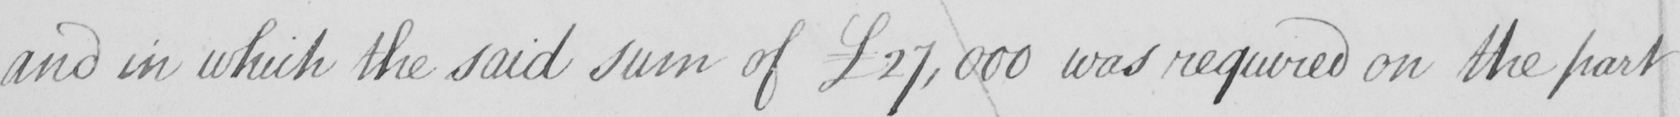Please provide the text content of this handwritten line. and in which the said sum of £27,000 was required on the part 